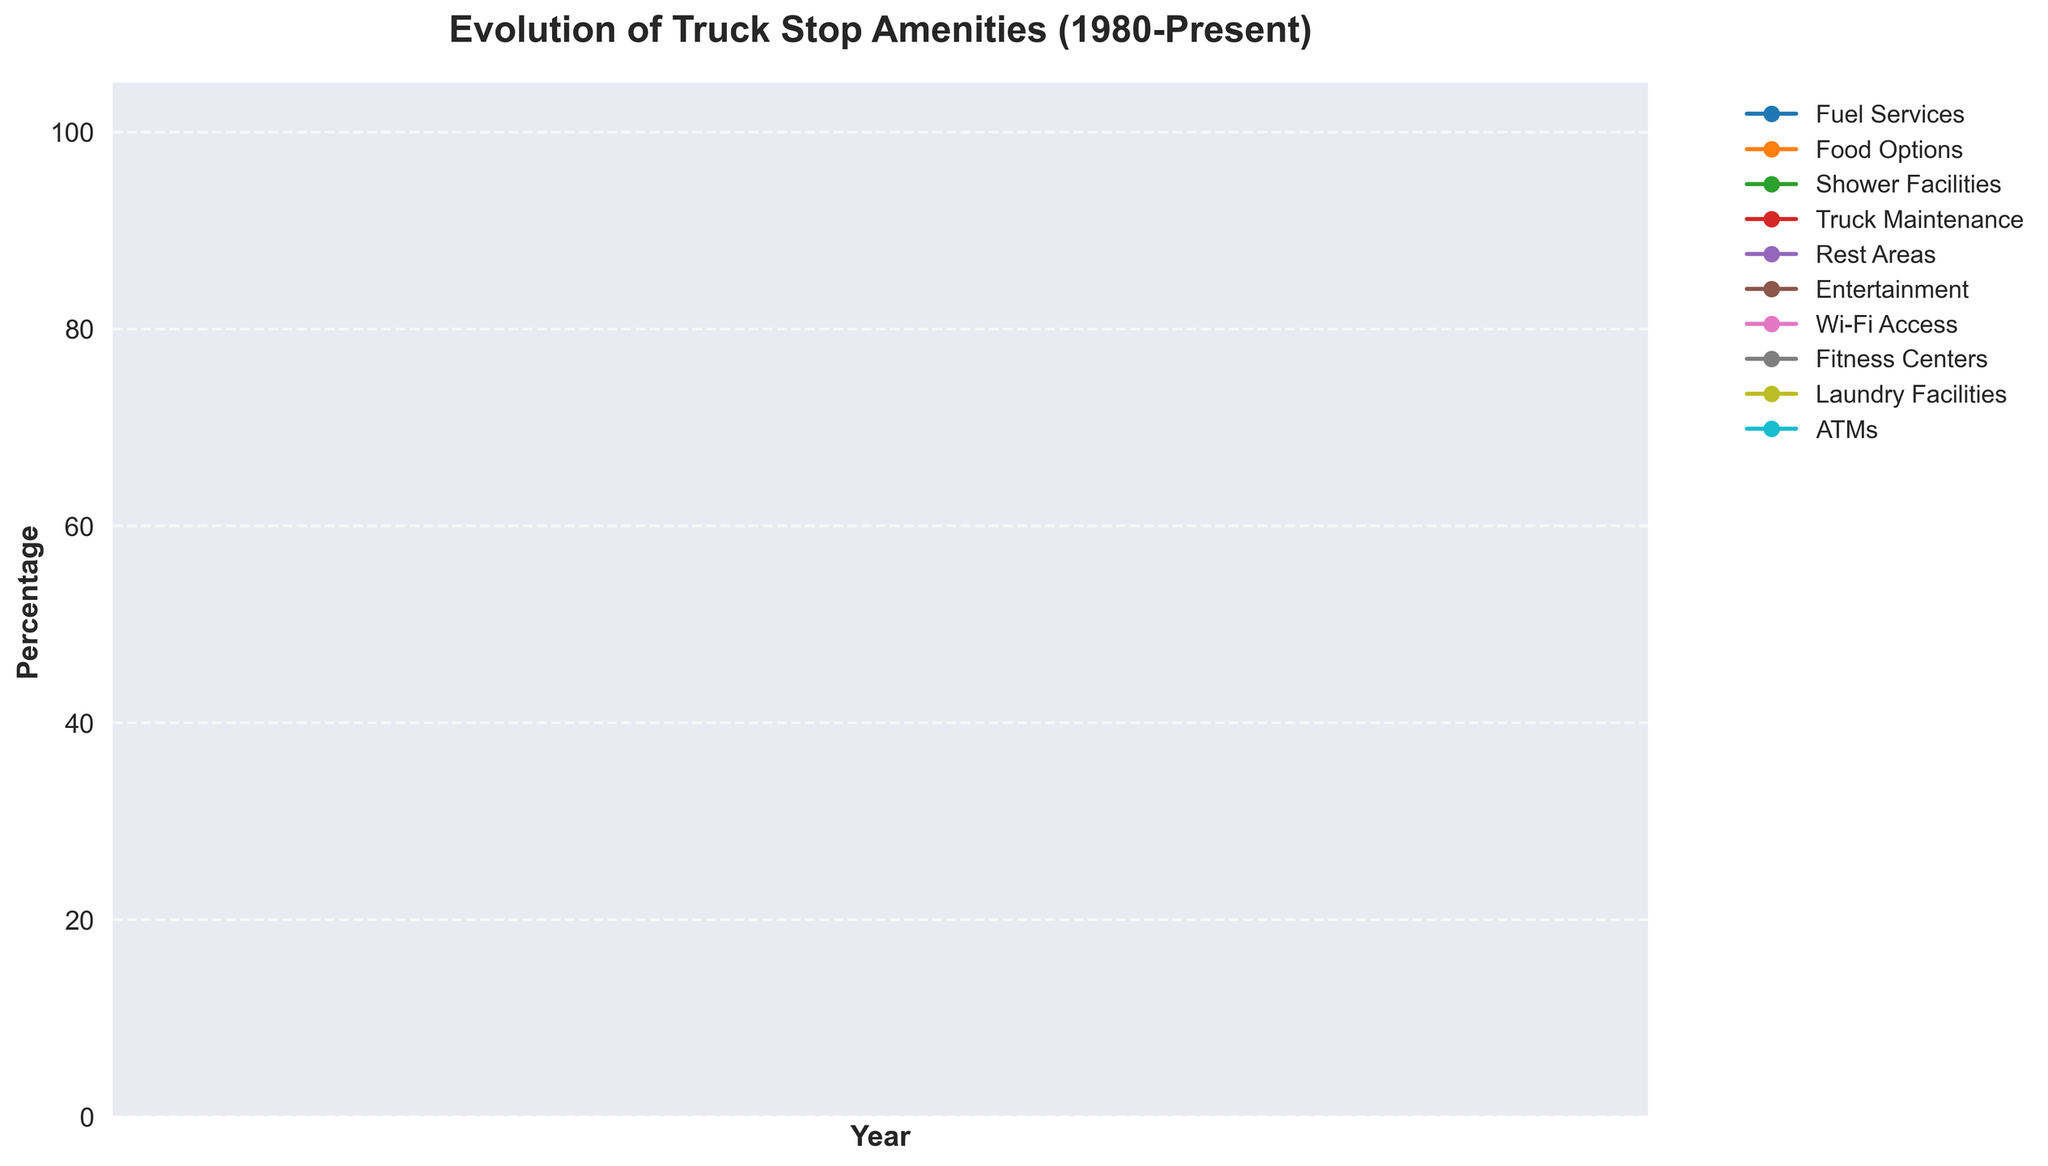When did Wi-Fi Access first appear in truck stops according to the chart? Wi-Fi Access first shows up in the data at a non-zero value. In the data provided, this occurs in 1995.
Answer: 1995 Which year saw the largest increase in Food Options? Look for the year-to-year differences in the Food Options series and identify the largest change. The increase from 1985 to 1990 is the largest, from 40 to 55.
Answer: 1985 to 1990 By how much did Shower Facilities increase between 1985 and 2000? Subtract the value of Shower Facilities in 1985 from its value in 2000. (70 - 20 = 50)
Answer: 50 Are Fuel Services always at 100%? Observing the line for Fuel Services across the entire timeline, it starts at 100 and remains constant without any dips.
Answer: Yes Which amenity reached 100% availability first? Examine the year at which each amenity reaches 100% for the first time. Fuel Services are already at 100% from the start.
Answer: Fuel Services Did Rest Areas ever drop in availability from one year to the next? Looking at the trend of Rest Areas, the line only increases or stays the same from year to year.
Answer: No Which amenities were added to truck stops between 2010 and 2015? Compare the amenities available in 2010 to those in 2015. Fitness Centers and Laundry Facilities show a notable increase in this period.
Answer: Fitness Centers and Laundry Facilities How many amenities reached 100% availability by 2020? Count the amenities that are at 100% in the year 2020 from the data. There are seven: Fuel Services, Food Options, Shower Facilities, Truck Maintenance, Rest Areas, Wi-Fi Access, and ATMs.
Answer: Seven From 1990 to 2010, which amenity showed the least growth? Compute the increase for each amenity over this period and identify the smallest value. Fuel Services remained at 100%, showing zero growth.
Answer: Fuel Services Between 1995 and 2000, which amenity saw the highest percentage increase? Calculate the percentage increase for each amenity from 1995 to 2000: ((New Value - Old Value) / Old Value) * 100. Wi-Fi Access increased from 5 to 20 showing a 300% increase which is the highest.
Answer: Wi-Fi Access 